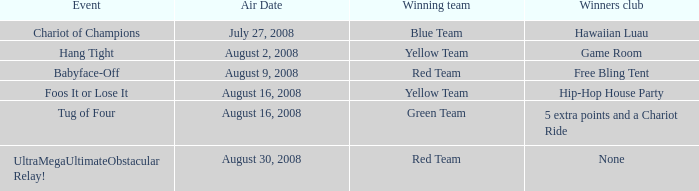Which winners club hosts a hang tight event? Game Room. 